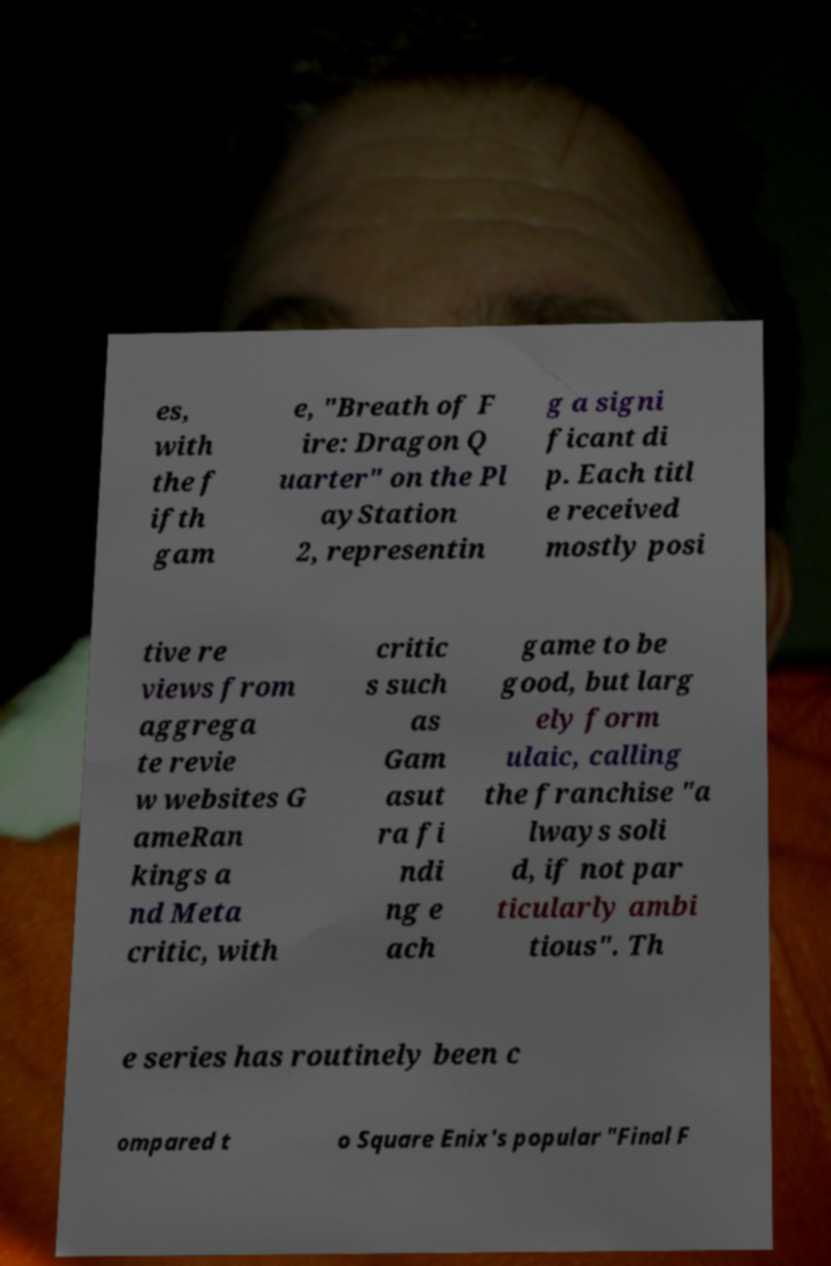Could you extract and type out the text from this image? es, with the f ifth gam e, "Breath of F ire: Dragon Q uarter" on the Pl ayStation 2, representin g a signi ficant di p. Each titl e received mostly posi tive re views from aggrega te revie w websites G ameRan kings a nd Meta critic, with critic s such as Gam asut ra fi ndi ng e ach game to be good, but larg ely form ulaic, calling the franchise "a lways soli d, if not par ticularly ambi tious". Th e series has routinely been c ompared t o Square Enix's popular "Final F 